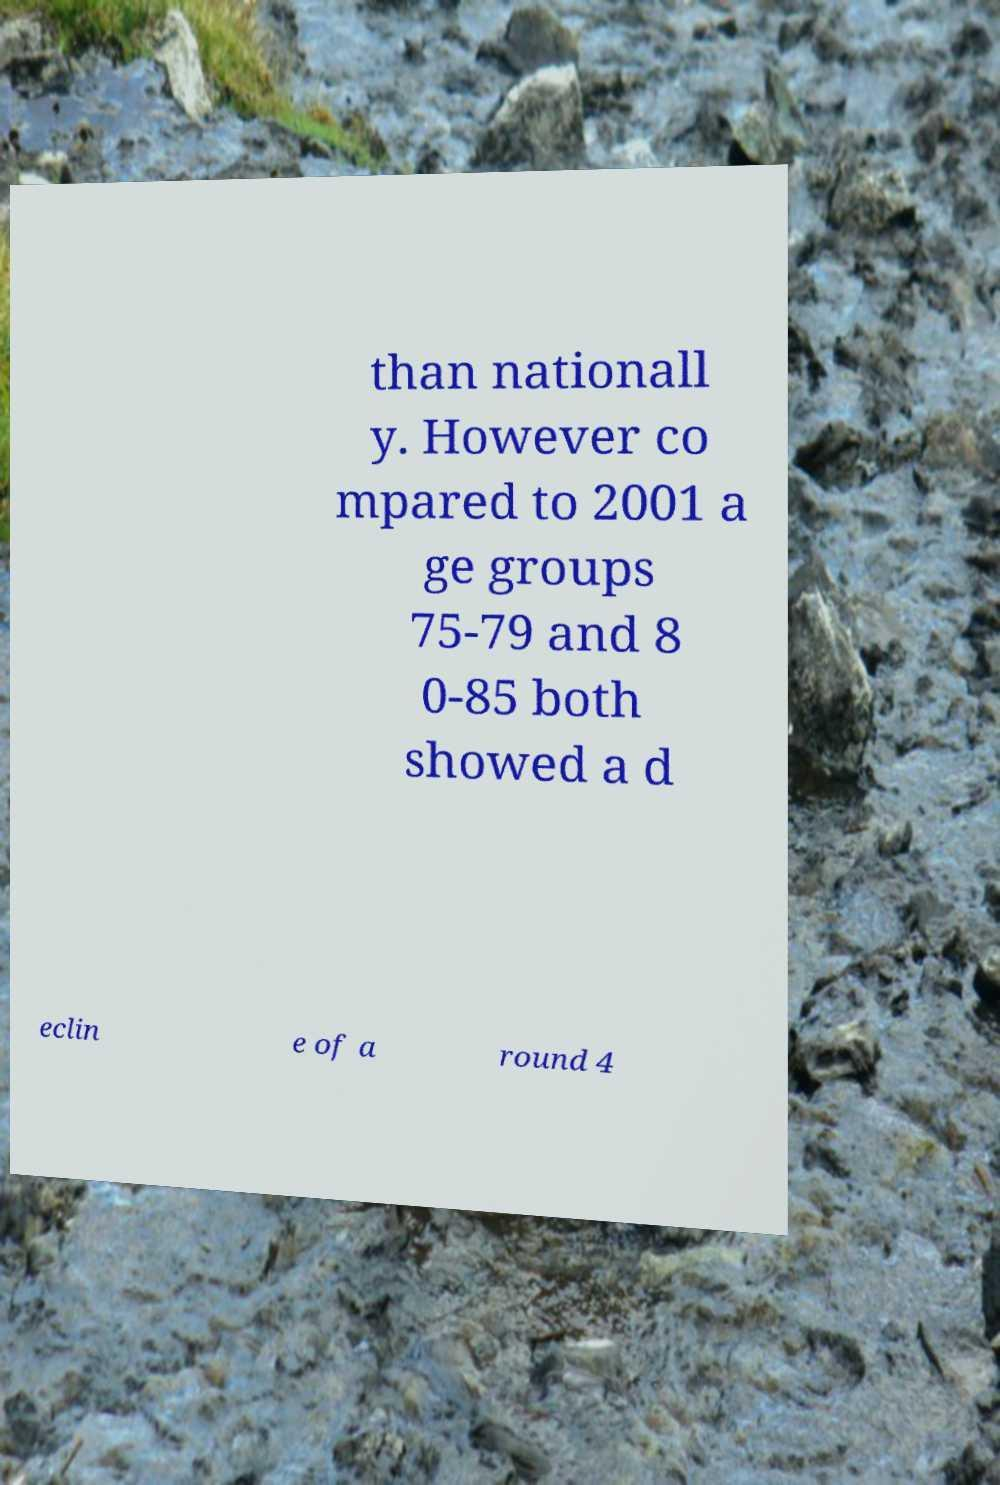What messages or text are displayed in this image? I need them in a readable, typed format. than nationall y. However co mpared to 2001 a ge groups 75-79 and 8 0-85 both showed a d eclin e of a round 4 